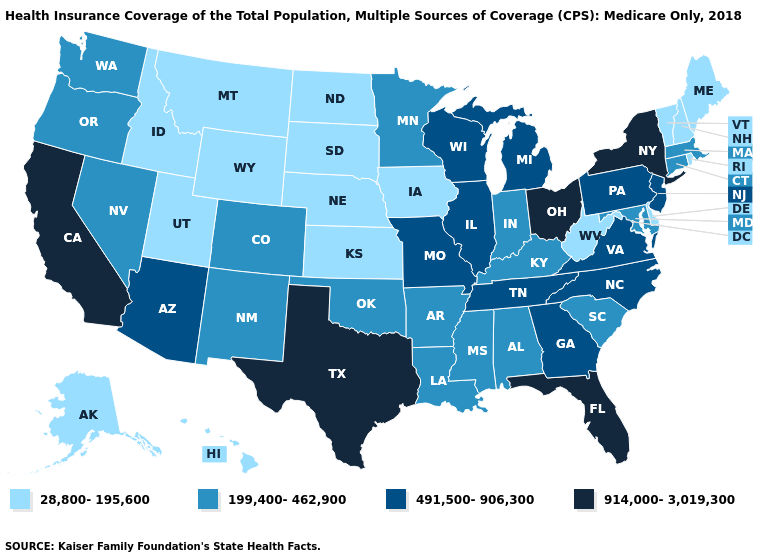How many symbols are there in the legend?
Short answer required. 4. How many symbols are there in the legend?
Answer briefly. 4. Name the states that have a value in the range 491,500-906,300?
Be succinct. Arizona, Georgia, Illinois, Michigan, Missouri, New Jersey, North Carolina, Pennsylvania, Tennessee, Virginia, Wisconsin. Does California have the highest value in the West?
Short answer required. Yes. What is the highest value in the USA?
Give a very brief answer. 914,000-3,019,300. Does Missouri have a higher value than Maryland?
Concise answer only. Yes. What is the value of South Carolina?
Quick response, please. 199,400-462,900. What is the highest value in the USA?
Be succinct. 914,000-3,019,300. Does Illinois have the same value as Arizona?
Short answer required. Yes. Does Maine have the same value as Nebraska?
Answer briefly. Yes. Which states have the highest value in the USA?
Quick response, please. California, Florida, New York, Ohio, Texas. What is the lowest value in the USA?
Keep it brief. 28,800-195,600. Does Florida have the same value as New York?
Short answer required. Yes. What is the highest value in the West ?
Concise answer only. 914,000-3,019,300. 